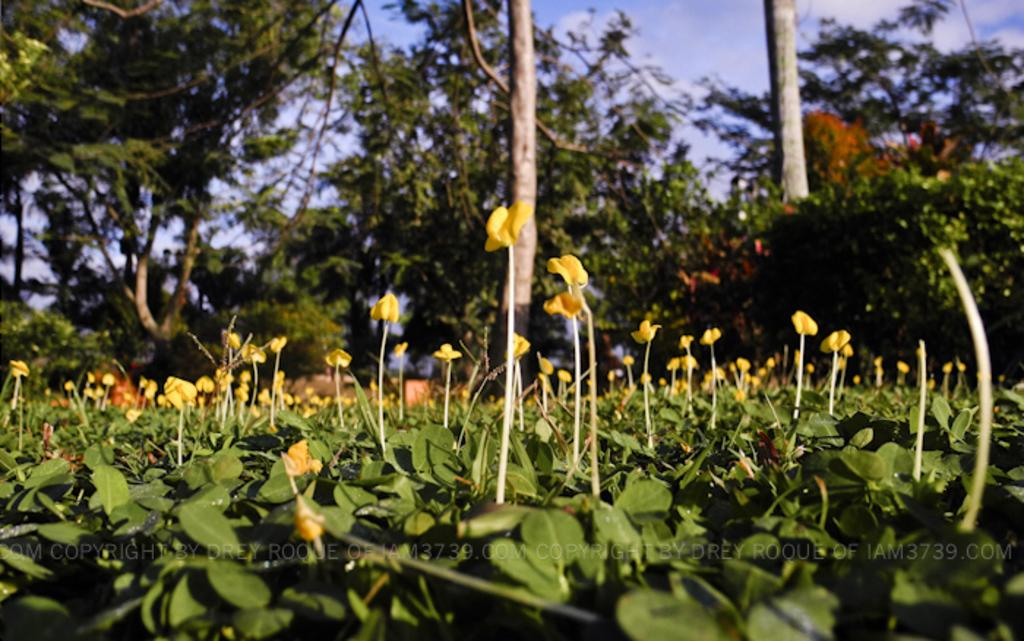What type of vegetation can be seen in the image? There are plants and trees in the image. Are there any specific features of the plants in the image? Yes, there are flowers visible on the plants. Is there any text present in the image? Yes, there is some text in the image. What can be seen in the sky at the top of the image? There are clouds visible in the sky at the top of the image. Where is the pocket located in the image? There is no pocket present in the image. What type of floor can be seen in the image? There is no floor visible in the image; it appears to be an outdoor scene with plants, trees, and sky. 